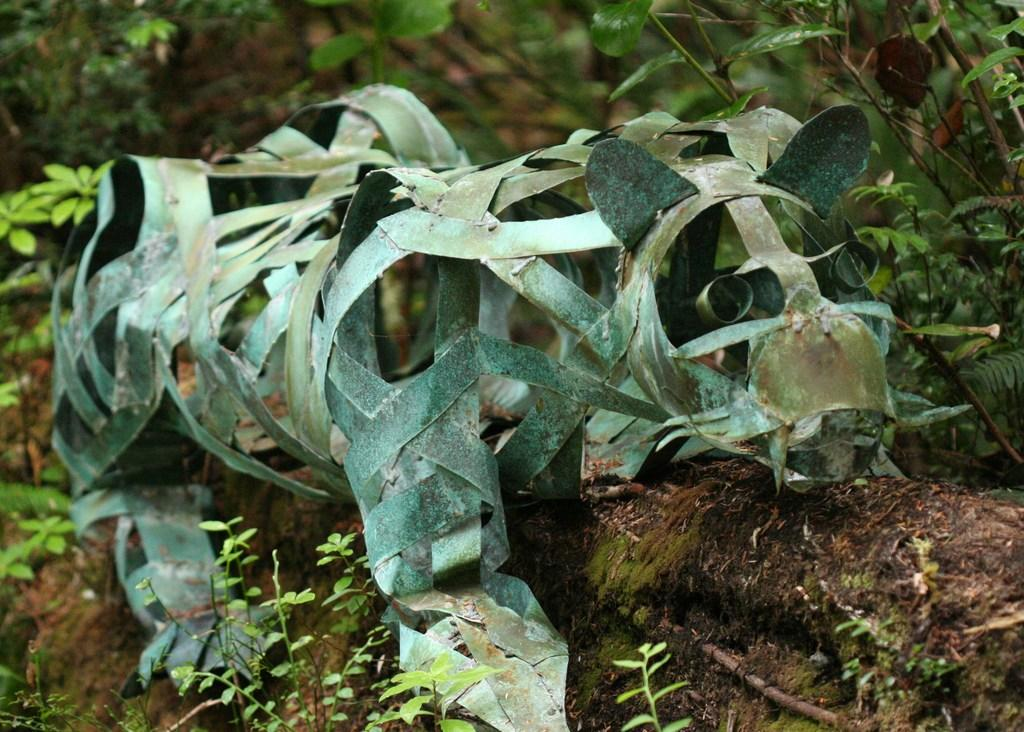What type of sculpture is in the image? There is a reptile sculpture in the image. What material was used to create the sculpture? The sculpture is made from coconut tree leaves. What can be seen behind the sculpture in the image? There are plants behind the sculpture in the image. How many rings are stacked on the pump in the image? There is no pump or rings present in the image; it features a reptile sculpture made from coconut tree leaves with plants behind it. 